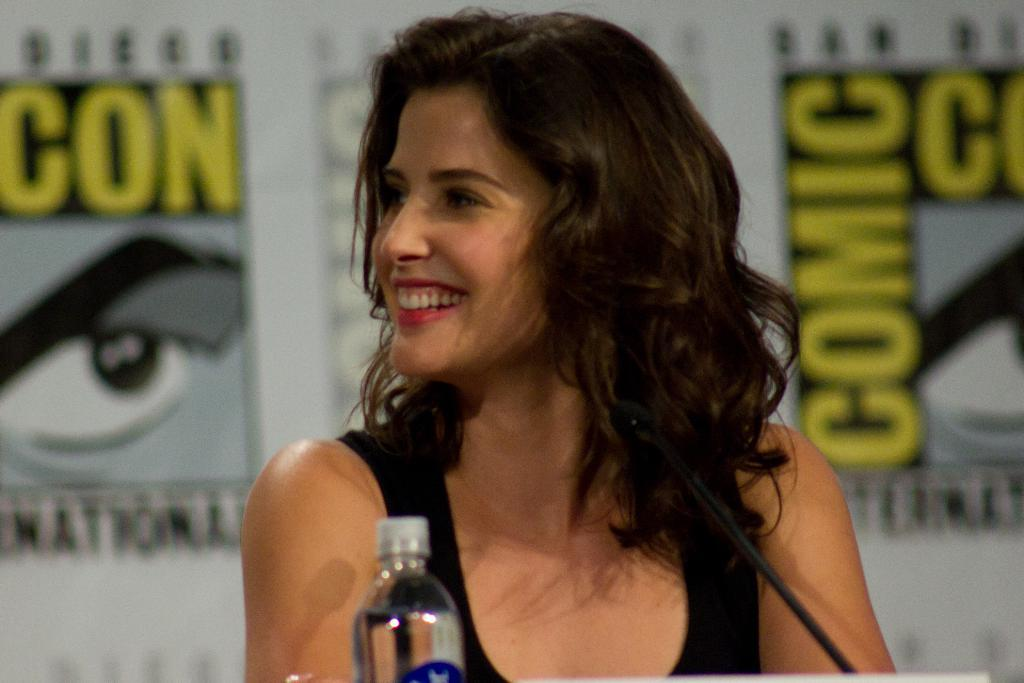Who is the main subject in the image? There is a lady person in the image. What is the lady person wearing? The lady person is wearing a black color tank top. What object is in front of the lady person? There is a microphone in front of the lady person. What can be seen next to the microphone? There is a water bottle in front of the lady person. What type of robin can be seen flying in the image? There is no robin present in the image; it features a lady person with a microphone and a water bottle. 